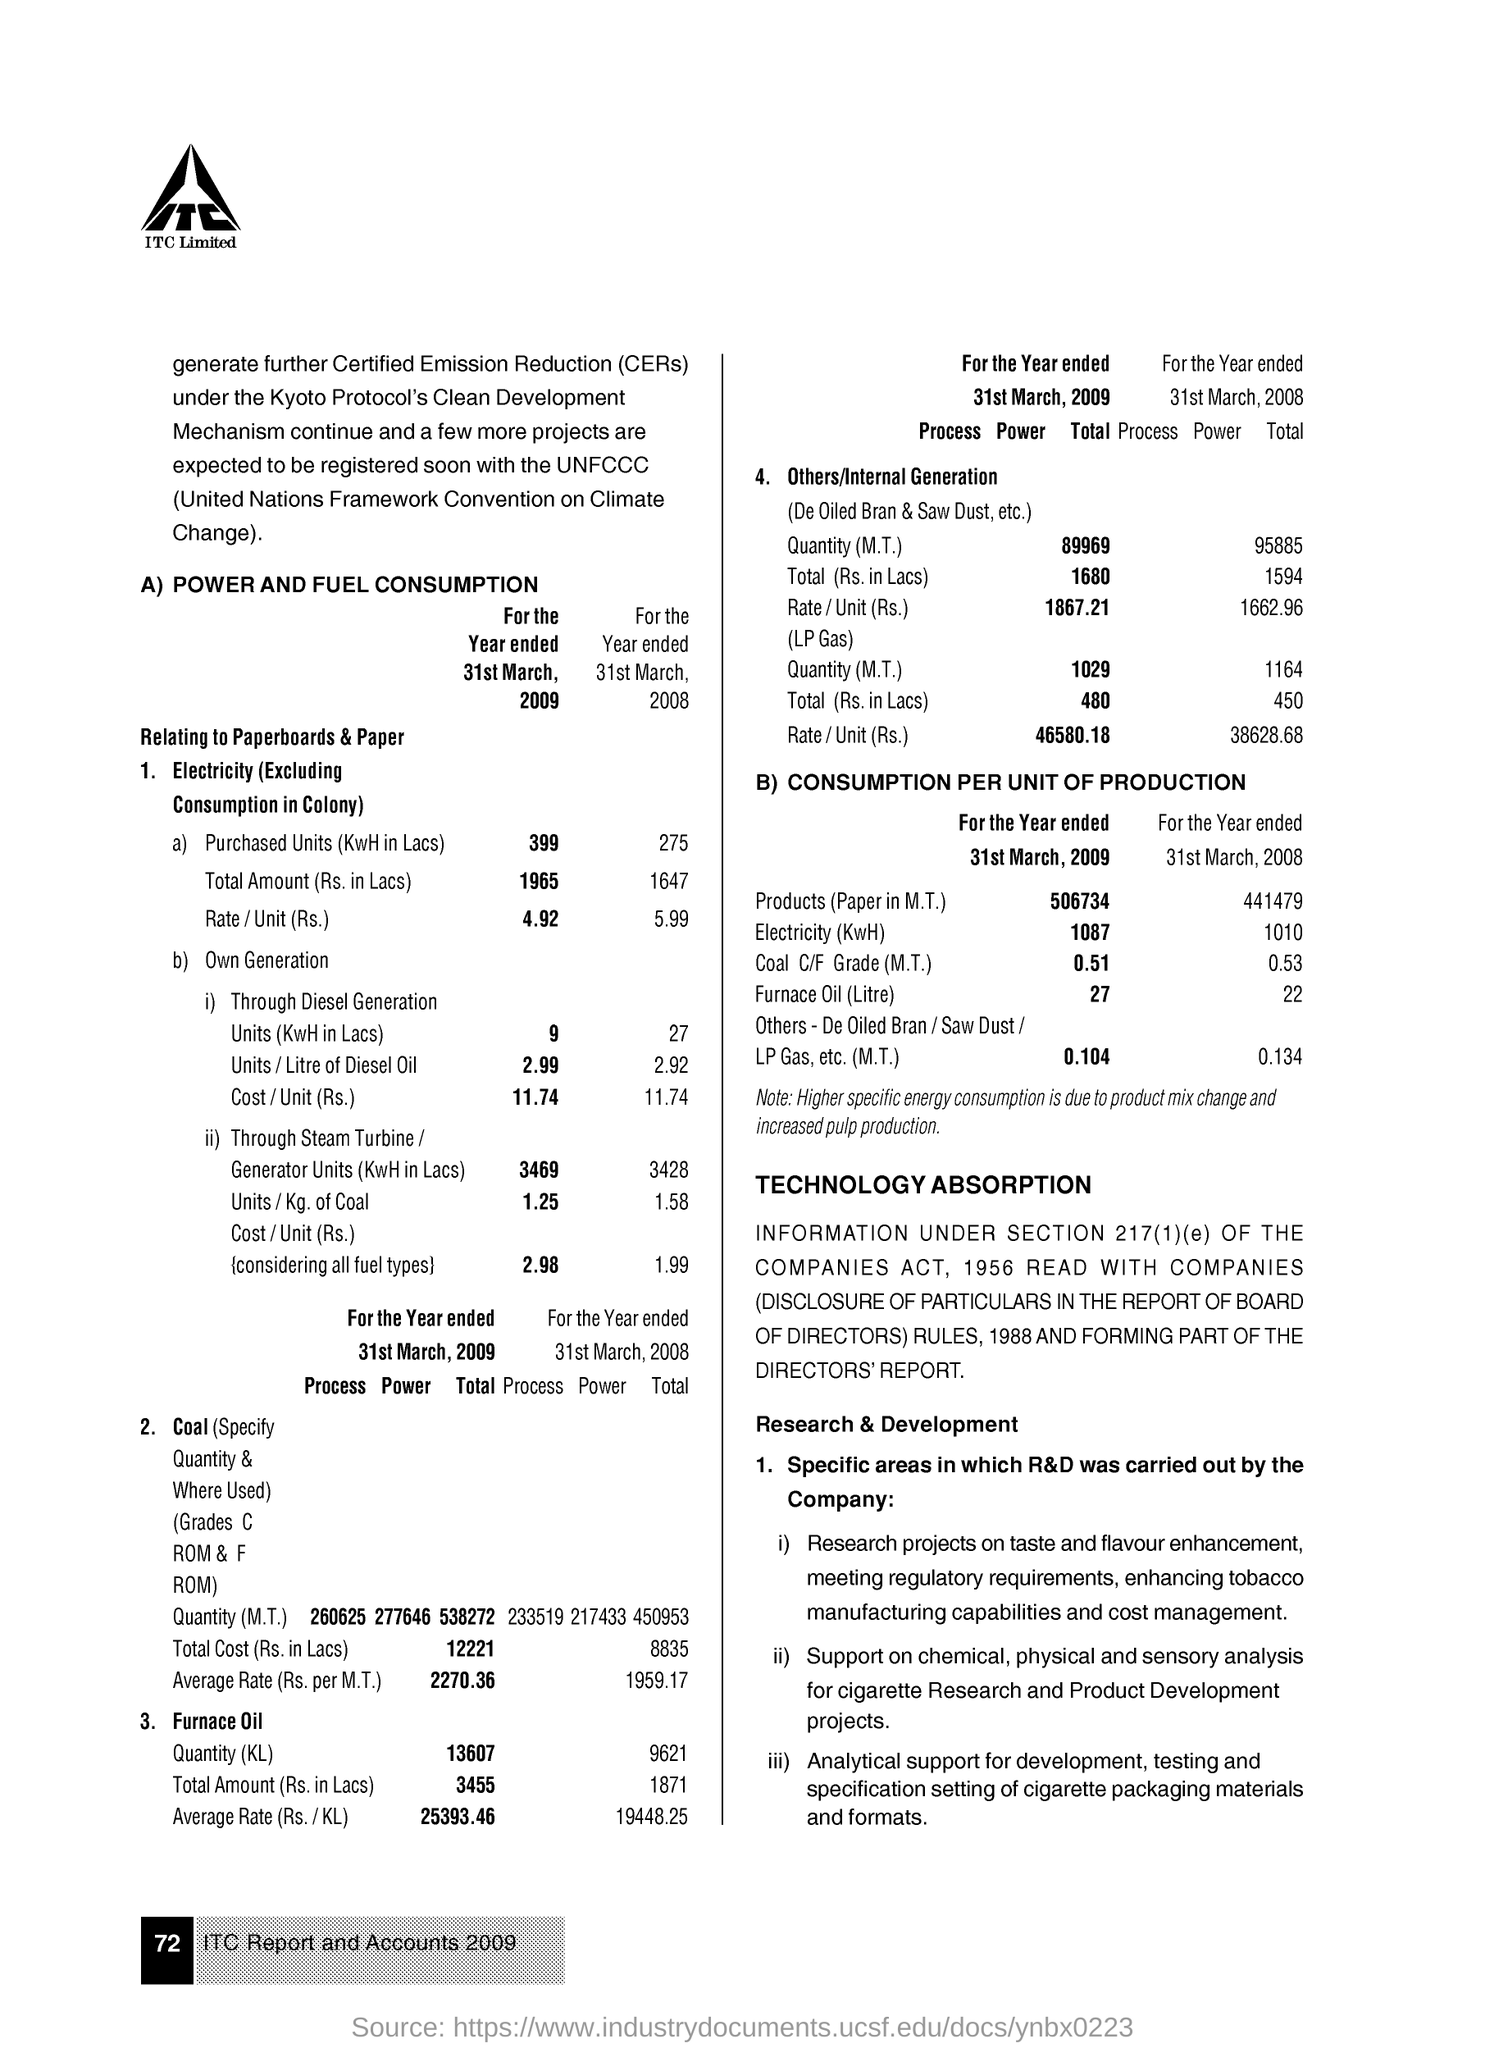Specify some key components in this picture. On March 31, 2009, the rate of electricity was 4.92 rupees per unit. On March 31st, 2009, a total of 3469 units of electricity were produced through the use of steam turbines and generators. On March 31, 2009, a unit of electricity was purchased. 